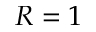<formula> <loc_0><loc_0><loc_500><loc_500>R = 1</formula> 